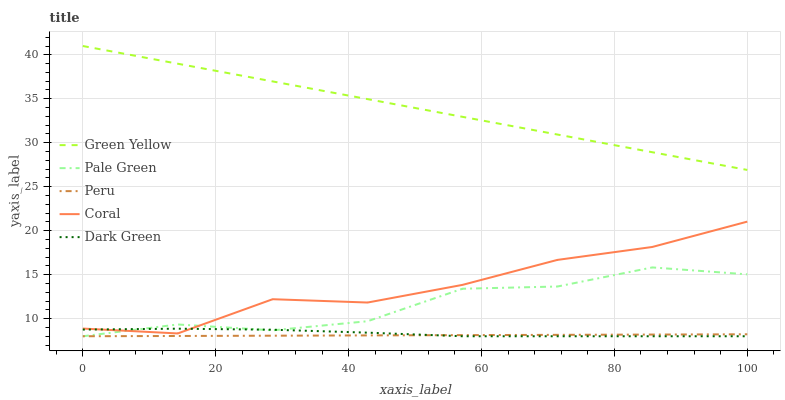Does Peru have the minimum area under the curve?
Answer yes or no. Yes. Does Green Yellow have the maximum area under the curve?
Answer yes or no. Yes. Does Coral have the minimum area under the curve?
Answer yes or no. No. Does Coral have the maximum area under the curve?
Answer yes or no. No. Is Peru the smoothest?
Answer yes or no. Yes. Is Coral the roughest?
Answer yes or no. Yes. Is Green Yellow the smoothest?
Answer yes or no. No. Is Green Yellow the roughest?
Answer yes or no. No. Does Pale Green have the lowest value?
Answer yes or no. Yes. Does Coral have the lowest value?
Answer yes or no. No. Does Green Yellow have the highest value?
Answer yes or no. Yes. Does Coral have the highest value?
Answer yes or no. No. Is Peru less than Green Yellow?
Answer yes or no. Yes. Is Green Yellow greater than Pale Green?
Answer yes or no. Yes. Does Coral intersect Pale Green?
Answer yes or no. Yes. Is Coral less than Pale Green?
Answer yes or no. No. Is Coral greater than Pale Green?
Answer yes or no. No. Does Peru intersect Green Yellow?
Answer yes or no. No. 